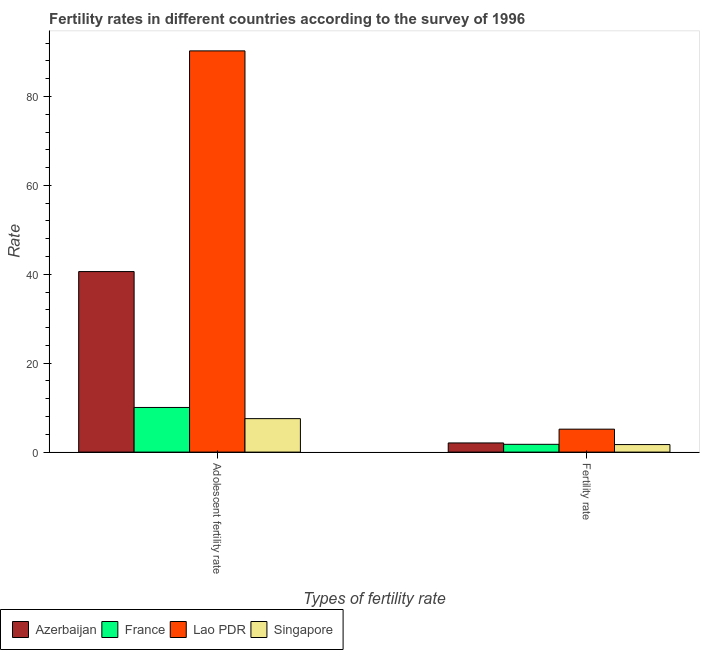How many groups of bars are there?
Your answer should be compact. 2. What is the label of the 2nd group of bars from the left?
Make the answer very short. Fertility rate. What is the fertility rate in Azerbaijan?
Keep it short and to the point. 2.06. Across all countries, what is the maximum fertility rate?
Your answer should be compact. 5.16. Across all countries, what is the minimum fertility rate?
Offer a terse response. 1.7. In which country was the fertility rate maximum?
Your answer should be compact. Lao PDR. In which country was the fertility rate minimum?
Provide a short and direct response. Singapore. What is the total adolescent fertility rate in the graph?
Your answer should be compact. 148.46. What is the difference between the fertility rate in Singapore and that in France?
Your answer should be very brief. -0.05. What is the difference between the fertility rate in Singapore and the adolescent fertility rate in France?
Make the answer very short. -8.35. What is the average fertility rate per country?
Keep it short and to the point. 2.67. What is the difference between the fertility rate and adolescent fertility rate in Lao PDR?
Ensure brevity in your answer.  -85.11. What is the ratio of the adolescent fertility rate in France to that in Singapore?
Offer a terse response. 1.33. Is the adolescent fertility rate in Azerbaijan less than that in Lao PDR?
Ensure brevity in your answer.  Yes. What does the 4th bar from the right in Fertility rate represents?
Keep it short and to the point. Azerbaijan. How many bars are there?
Offer a very short reply. 8. How many countries are there in the graph?
Offer a terse response. 4. What is the difference between two consecutive major ticks on the Y-axis?
Your answer should be very brief. 20. Where does the legend appear in the graph?
Offer a very short reply. Bottom left. How are the legend labels stacked?
Make the answer very short. Horizontal. What is the title of the graph?
Provide a short and direct response. Fertility rates in different countries according to the survey of 1996. Does "Channel Islands" appear as one of the legend labels in the graph?
Keep it short and to the point. No. What is the label or title of the X-axis?
Provide a short and direct response. Types of fertility rate. What is the label or title of the Y-axis?
Keep it short and to the point. Rate. What is the Rate of Azerbaijan in Adolescent fertility rate?
Give a very brief answer. 40.62. What is the Rate of France in Adolescent fertility rate?
Provide a short and direct response. 10.04. What is the Rate of Lao PDR in Adolescent fertility rate?
Provide a succinct answer. 90.27. What is the Rate in Singapore in Adolescent fertility rate?
Your answer should be compact. 7.53. What is the Rate in Azerbaijan in Fertility rate?
Offer a terse response. 2.06. What is the Rate of France in Fertility rate?
Keep it short and to the point. 1.75. What is the Rate in Lao PDR in Fertility rate?
Provide a short and direct response. 5.16. What is the Rate in Singapore in Fertility rate?
Give a very brief answer. 1.7. Across all Types of fertility rate, what is the maximum Rate of Azerbaijan?
Offer a very short reply. 40.62. Across all Types of fertility rate, what is the maximum Rate of France?
Your answer should be very brief. 10.04. Across all Types of fertility rate, what is the maximum Rate in Lao PDR?
Your response must be concise. 90.27. Across all Types of fertility rate, what is the maximum Rate in Singapore?
Your answer should be very brief. 7.53. Across all Types of fertility rate, what is the minimum Rate in Azerbaijan?
Offer a very short reply. 2.06. Across all Types of fertility rate, what is the minimum Rate of France?
Give a very brief answer. 1.75. Across all Types of fertility rate, what is the minimum Rate of Lao PDR?
Give a very brief answer. 5.16. Across all Types of fertility rate, what is the minimum Rate of Singapore?
Provide a succinct answer. 1.7. What is the total Rate of Azerbaijan in the graph?
Your answer should be very brief. 42.68. What is the total Rate of France in the graph?
Keep it short and to the point. 11.79. What is the total Rate in Lao PDR in the graph?
Offer a very short reply. 95.43. What is the total Rate of Singapore in the graph?
Keep it short and to the point. 9.23. What is the difference between the Rate in Azerbaijan in Adolescent fertility rate and that in Fertility rate?
Your response must be concise. 38.56. What is the difference between the Rate in France in Adolescent fertility rate and that in Fertility rate?
Offer a terse response. 8.29. What is the difference between the Rate in Lao PDR in Adolescent fertility rate and that in Fertility rate?
Ensure brevity in your answer.  85.11. What is the difference between the Rate in Singapore in Adolescent fertility rate and that in Fertility rate?
Offer a very short reply. 5.83. What is the difference between the Rate of Azerbaijan in Adolescent fertility rate and the Rate of France in Fertility rate?
Offer a very short reply. 38.87. What is the difference between the Rate of Azerbaijan in Adolescent fertility rate and the Rate of Lao PDR in Fertility rate?
Your answer should be very brief. 35.46. What is the difference between the Rate in Azerbaijan in Adolescent fertility rate and the Rate in Singapore in Fertility rate?
Keep it short and to the point. 38.92. What is the difference between the Rate of France in Adolescent fertility rate and the Rate of Lao PDR in Fertility rate?
Your answer should be compact. 4.88. What is the difference between the Rate of France in Adolescent fertility rate and the Rate of Singapore in Fertility rate?
Ensure brevity in your answer.  8.35. What is the difference between the Rate of Lao PDR in Adolescent fertility rate and the Rate of Singapore in Fertility rate?
Your answer should be very brief. 88.57. What is the average Rate in Azerbaijan per Types of fertility rate?
Provide a succinct answer. 21.34. What is the average Rate in France per Types of fertility rate?
Keep it short and to the point. 5.9. What is the average Rate in Lao PDR per Types of fertility rate?
Give a very brief answer. 47.72. What is the average Rate of Singapore per Types of fertility rate?
Ensure brevity in your answer.  4.61. What is the difference between the Rate in Azerbaijan and Rate in France in Adolescent fertility rate?
Make the answer very short. 30.57. What is the difference between the Rate in Azerbaijan and Rate in Lao PDR in Adolescent fertility rate?
Offer a very short reply. -49.65. What is the difference between the Rate of Azerbaijan and Rate of Singapore in Adolescent fertility rate?
Keep it short and to the point. 33.09. What is the difference between the Rate in France and Rate in Lao PDR in Adolescent fertility rate?
Ensure brevity in your answer.  -80.23. What is the difference between the Rate in France and Rate in Singapore in Adolescent fertility rate?
Offer a very short reply. 2.51. What is the difference between the Rate in Lao PDR and Rate in Singapore in Adolescent fertility rate?
Offer a very short reply. 82.74. What is the difference between the Rate of Azerbaijan and Rate of France in Fertility rate?
Provide a succinct answer. 0.31. What is the difference between the Rate of Azerbaijan and Rate of Lao PDR in Fertility rate?
Your answer should be compact. -3.1. What is the difference between the Rate of Azerbaijan and Rate of Singapore in Fertility rate?
Your answer should be compact. 0.36. What is the difference between the Rate in France and Rate in Lao PDR in Fertility rate?
Your answer should be very brief. -3.41. What is the difference between the Rate of France and Rate of Singapore in Fertility rate?
Provide a short and direct response. 0.05. What is the difference between the Rate in Lao PDR and Rate in Singapore in Fertility rate?
Offer a terse response. 3.47. What is the ratio of the Rate in Azerbaijan in Adolescent fertility rate to that in Fertility rate?
Your response must be concise. 19.72. What is the ratio of the Rate of France in Adolescent fertility rate to that in Fertility rate?
Provide a succinct answer. 5.74. What is the ratio of the Rate in Lao PDR in Adolescent fertility rate to that in Fertility rate?
Make the answer very short. 17.48. What is the ratio of the Rate of Singapore in Adolescent fertility rate to that in Fertility rate?
Provide a short and direct response. 4.44. What is the difference between the highest and the second highest Rate in Azerbaijan?
Keep it short and to the point. 38.56. What is the difference between the highest and the second highest Rate in France?
Ensure brevity in your answer.  8.29. What is the difference between the highest and the second highest Rate in Lao PDR?
Provide a succinct answer. 85.11. What is the difference between the highest and the second highest Rate in Singapore?
Give a very brief answer. 5.83. What is the difference between the highest and the lowest Rate of Azerbaijan?
Offer a terse response. 38.56. What is the difference between the highest and the lowest Rate of France?
Keep it short and to the point. 8.29. What is the difference between the highest and the lowest Rate of Lao PDR?
Your response must be concise. 85.11. What is the difference between the highest and the lowest Rate of Singapore?
Provide a succinct answer. 5.83. 